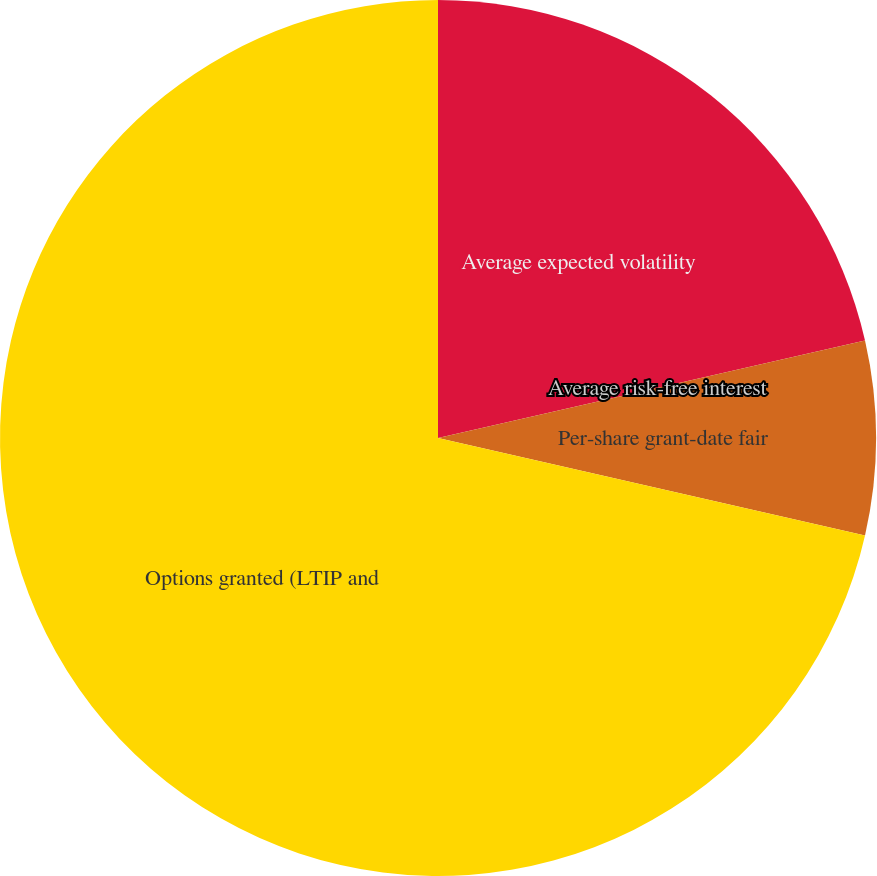Convert chart to OTSL. <chart><loc_0><loc_0><loc_500><loc_500><pie_chart><fcel>Average expected volatility<fcel>Average risk-free interest<fcel>Per-share grant-date fair<fcel>Options granted (LTIP and<nl><fcel>21.43%<fcel>0.0%<fcel>7.14%<fcel>71.43%<nl></chart> 